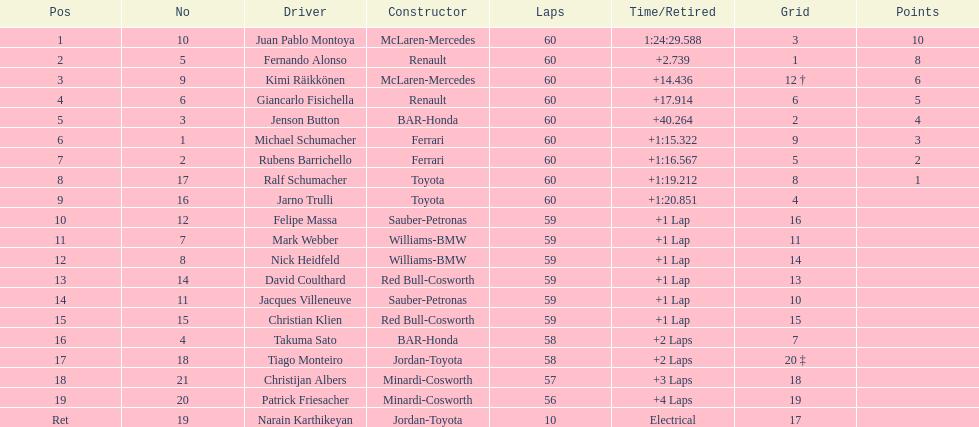Which driver came after giancarlo fisichella? Jenson Button. 